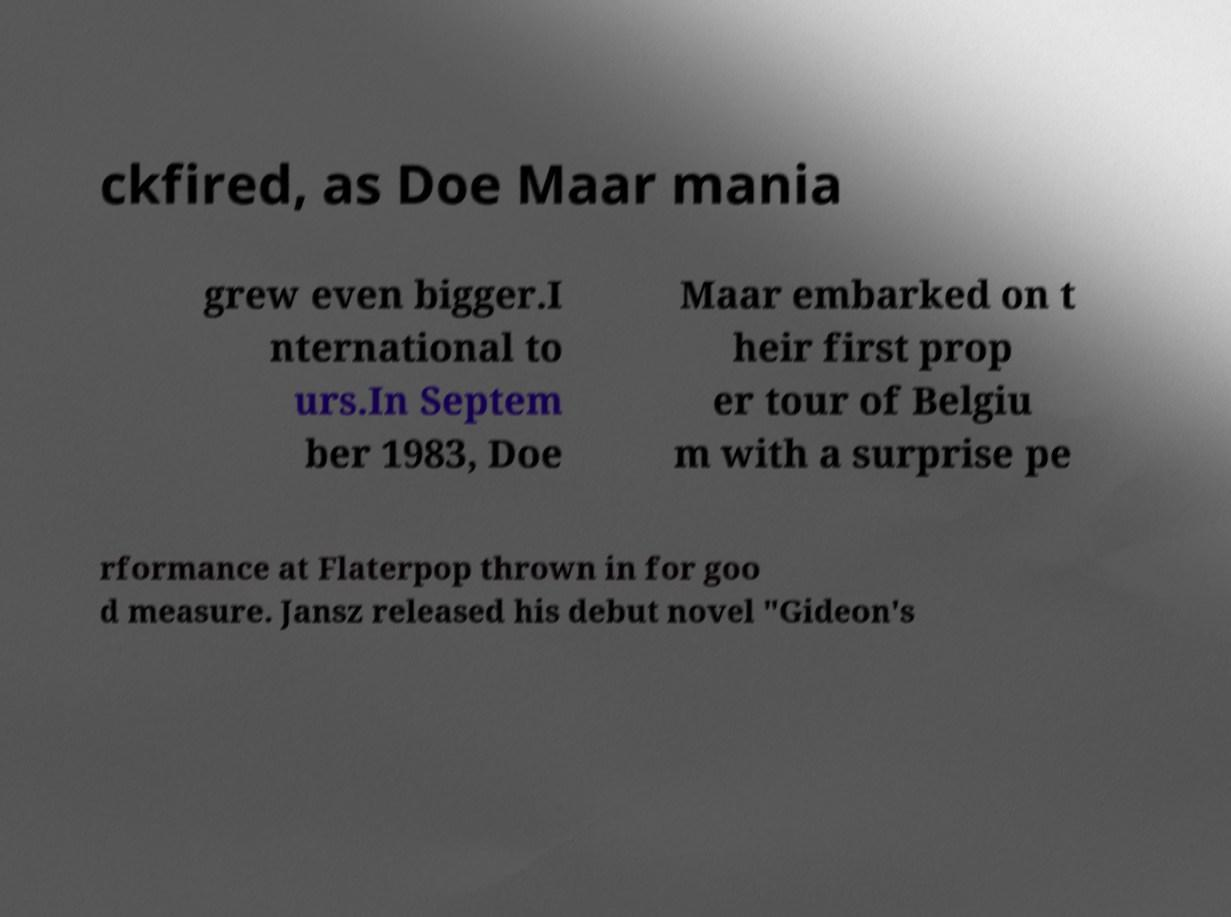Can you read and provide the text displayed in the image?This photo seems to have some interesting text. Can you extract and type it out for me? ckfired, as Doe Maar mania grew even bigger.I nternational to urs.In Septem ber 1983, Doe Maar embarked on t heir first prop er tour of Belgiu m with a surprise pe rformance at Flaterpop thrown in for goo d measure. Jansz released his debut novel "Gideon's 